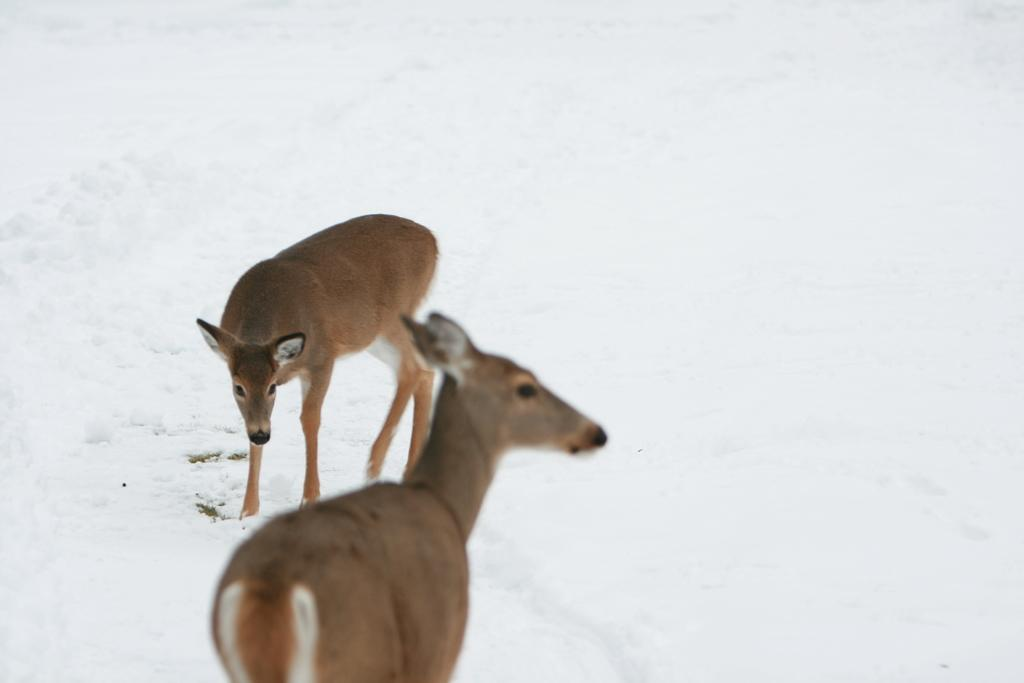How many animals are present in the image? There are two animals in the image. What is the surface on which the animals are standing? The animals are on the snow. What is the predominant color of the background in the image? The background of the image is white. Can you see any eggs in the quicksand in the image? There is no quicksand or eggs present in the image; it features two animals on the snow with a white background. 